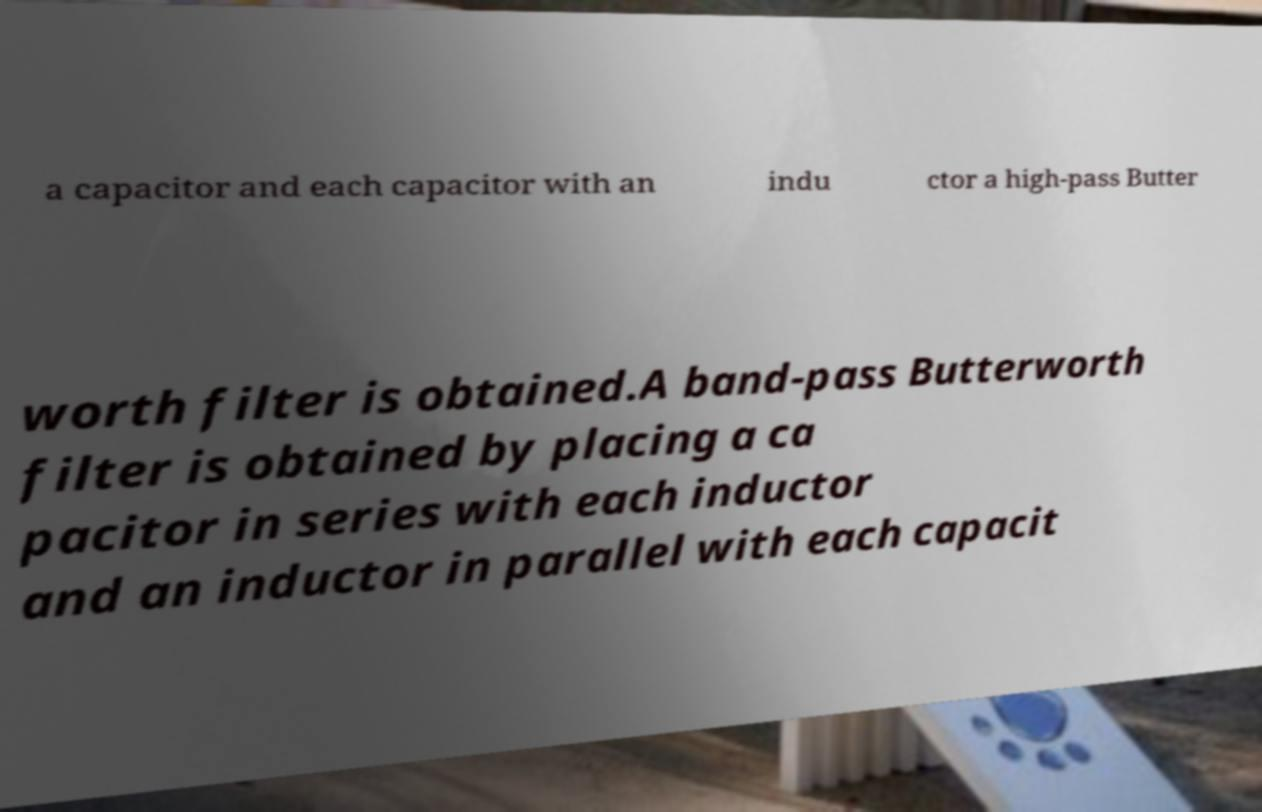There's text embedded in this image that I need extracted. Can you transcribe it verbatim? a capacitor and each capacitor with an indu ctor a high-pass Butter worth filter is obtained.A band-pass Butterworth filter is obtained by placing a ca pacitor in series with each inductor and an inductor in parallel with each capacit 